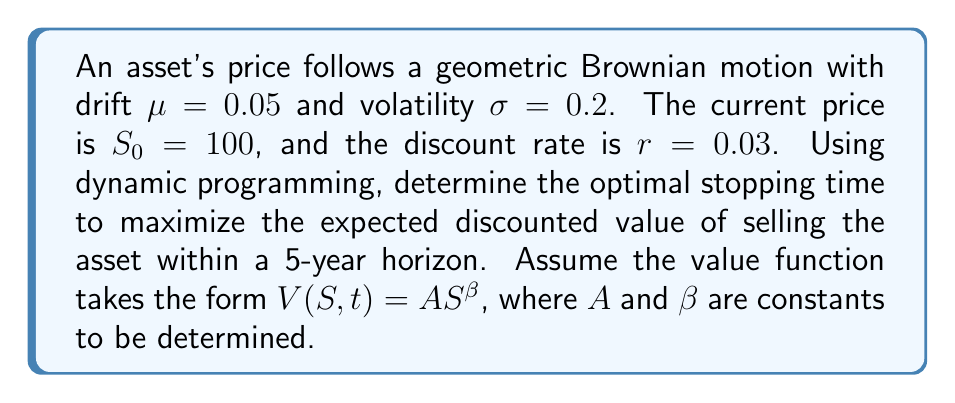Can you solve this math problem? 1) First, we need to set up the Hamilton-Jacobi-Bellman (HJB) equation:

   $$\max\{S - V, -\frac{\partial V}{\partial t} + \frac{1}{2}\sigma^2S^2\frac{\partial^2V}{\partial S^2} + \mu S\frac{\partial V}{\partial S} - rV\} = 0$$

2) Given $V(S,t) = AS^\beta$, we calculate the partial derivatives:

   $$\frac{\partial V}{\partial t} = 0$$
   $$\frac{\partial V}{\partial S} = A\beta S^{\beta-1}$$
   $$\frac{\partial^2V}{\partial S^2} = A\beta(\beta-1)S^{\beta-2}$$

3) Substituting these into the HJB equation:

   $$\frac{1}{2}\sigma^2S^2[A\beta(\beta-1)S^{\beta-2}] + \mu S[A\beta S^{\beta-1}] - rAS^\beta = 0$$

4) Simplifying:

   $$\frac{1}{2}\sigma^2\beta(\beta-1) + \mu\beta - r = 0$$

5) Substituting the given values:

   $$\frac{1}{2}(0.2)^2\beta(\beta-1) + 0.05\beta - 0.03 = 0$$

6) Solving this quadratic equation:

   $$0.02\beta^2 + 0.03\beta - 0.03 = 0$$

   The positive root is $\beta \approx 1.376$

7) The optimal stopping boundary is given by:

   $$S^* = \frac{\beta}{\beta-1}S_0 \approx 366.67$$

8) To find $A$, we use the value-matching condition:

   $$AS^{*\beta} = S^*$$

   $$A = (S^*)^{1-\beta} \approx 0.0122$$

9) The optimal stopping time is the first time the asset price reaches $S^*$ or the end of the 5-year horizon, whichever comes first.
Answer: Stop when $S_t \geq 366.67$ or $t = 5$, whichever occurs first. 